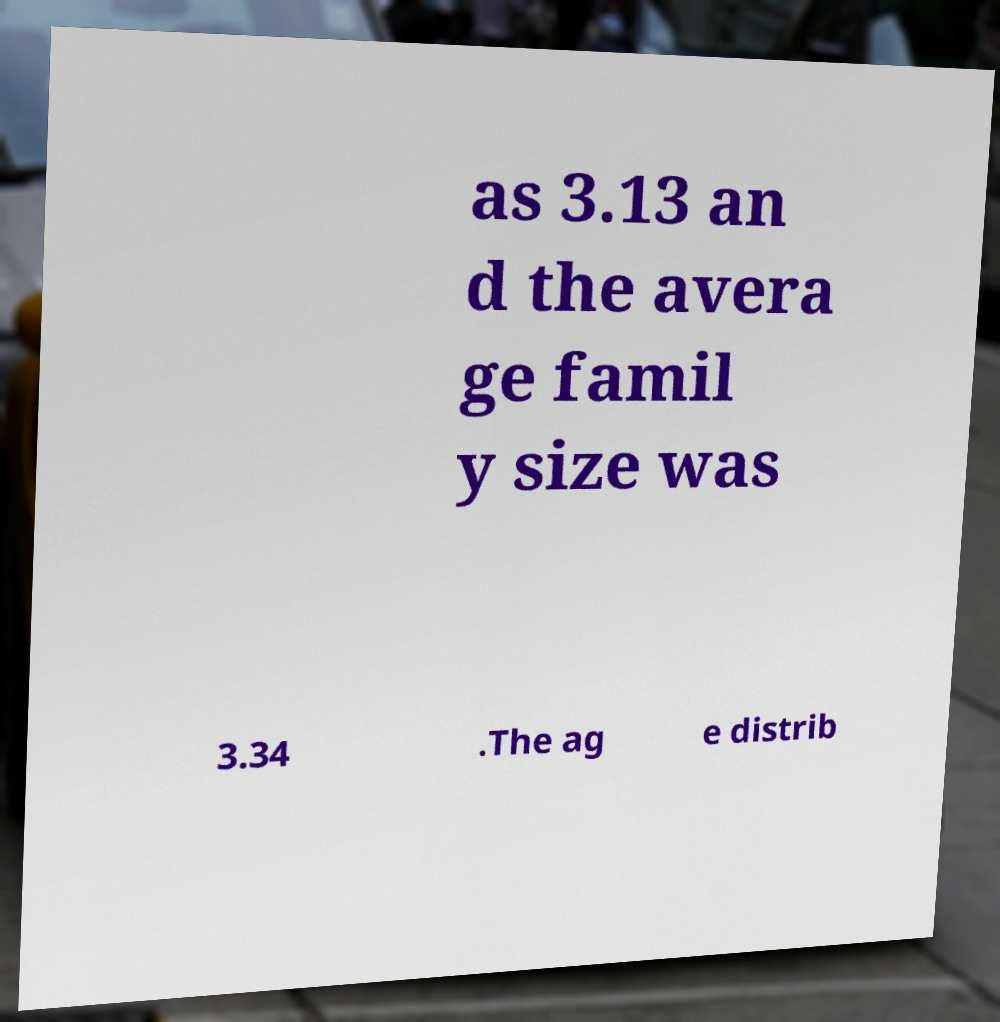Could you assist in decoding the text presented in this image and type it out clearly? as 3.13 an d the avera ge famil y size was 3.34 .The ag e distrib 